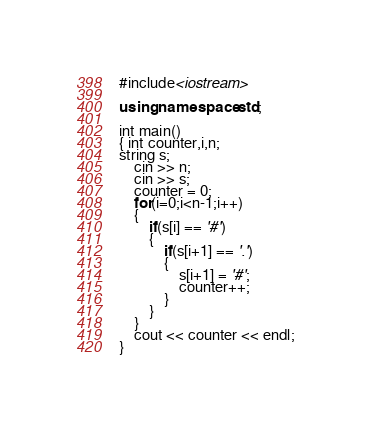<code> <loc_0><loc_0><loc_500><loc_500><_C++_>#include<iostream>

using namespace std;

int main()
{ int counter,i,n;
string s;
	cin >> n;
	cin >> s;
	counter = 0;
	for(i=0;i<n-1;i++)
	{
		if(s[i] == '#')
		{
			if(s[i+1] == '.')
			{
				s[i+1] = '#';
				counter++;
			}
		}
	}
	cout << counter << endl;
}</code> 